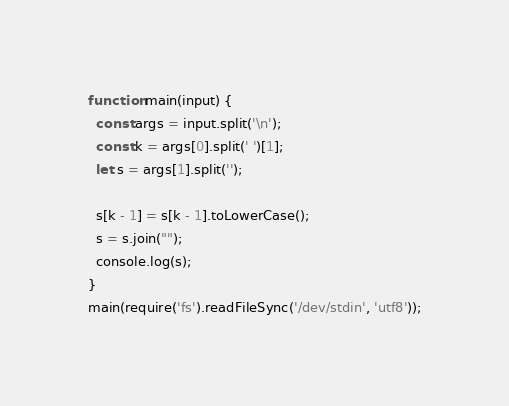Convert code to text. <code><loc_0><loc_0><loc_500><loc_500><_JavaScript_>function main(input) {
  const args = input.split('\n');
  const k = args[0].split(' ')[1];
  let s = args[1].split('');
  
  s[k - 1] = s[k - 1].toLowerCase();
  s = s.join("");
  console.log(s);
}
main(require('fs').readFileSync('/dev/stdin', 'utf8'));</code> 